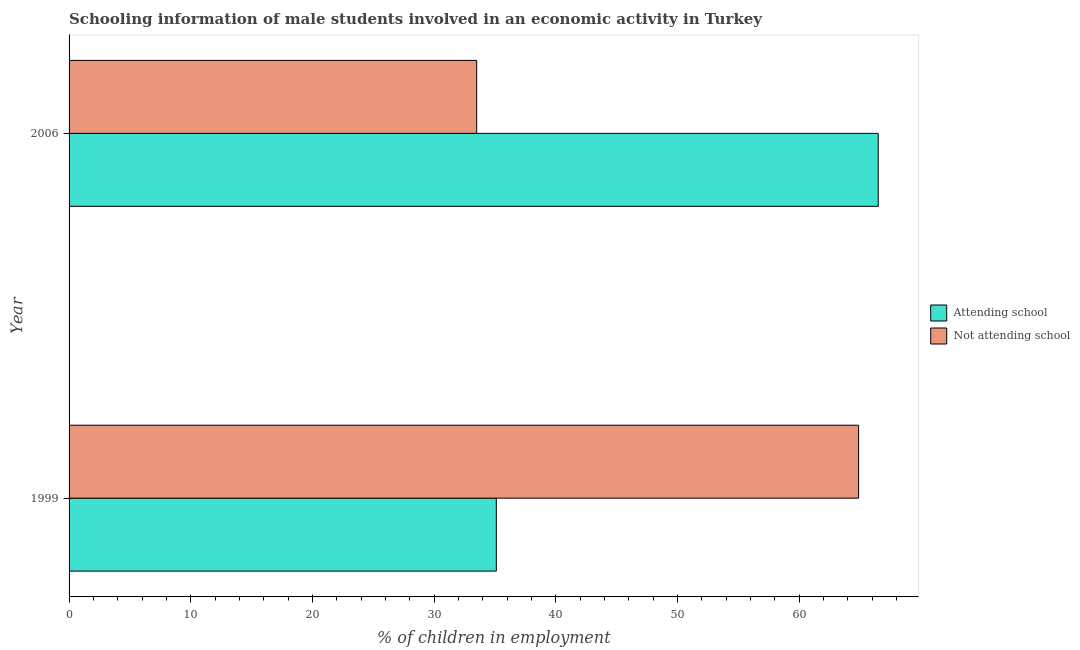Are the number of bars per tick equal to the number of legend labels?
Provide a succinct answer. Yes. Are the number of bars on each tick of the Y-axis equal?
Provide a short and direct response. Yes. How many bars are there on the 2nd tick from the bottom?
Your answer should be very brief. 2. What is the label of the 2nd group of bars from the top?
Give a very brief answer. 1999. What is the percentage of employed males who are attending school in 1999?
Your answer should be very brief. 35.11. Across all years, what is the maximum percentage of employed males who are attending school?
Your response must be concise. 66.5. Across all years, what is the minimum percentage of employed males who are not attending school?
Your response must be concise. 33.5. In which year was the percentage of employed males who are attending school minimum?
Keep it short and to the point. 1999. What is the total percentage of employed males who are not attending school in the graph?
Give a very brief answer. 98.39. What is the difference between the percentage of employed males who are attending school in 1999 and that in 2006?
Your answer should be very brief. -31.39. What is the difference between the percentage of employed males who are attending school in 2006 and the percentage of employed males who are not attending school in 1999?
Your response must be concise. 1.61. What is the average percentage of employed males who are not attending school per year?
Your answer should be compact. 49.19. In the year 2006, what is the difference between the percentage of employed males who are not attending school and percentage of employed males who are attending school?
Your answer should be very brief. -33. In how many years, is the percentage of employed males who are attending school greater than 56 %?
Provide a succinct answer. 1. What is the ratio of the percentage of employed males who are attending school in 1999 to that in 2006?
Offer a terse response. 0.53. Is the percentage of employed males who are attending school in 1999 less than that in 2006?
Provide a short and direct response. Yes. Is the difference between the percentage of employed males who are attending school in 1999 and 2006 greater than the difference between the percentage of employed males who are not attending school in 1999 and 2006?
Your answer should be compact. No. What does the 1st bar from the top in 2006 represents?
Your response must be concise. Not attending school. What does the 1st bar from the bottom in 1999 represents?
Offer a very short reply. Attending school. Does the graph contain any zero values?
Offer a very short reply. No. Does the graph contain grids?
Keep it short and to the point. No. How many legend labels are there?
Offer a very short reply. 2. What is the title of the graph?
Provide a short and direct response. Schooling information of male students involved in an economic activity in Turkey. Does "GDP at market prices" appear as one of the legend labels in the graph?
Make the answer very short. No. What is the label or title of the X-axis?
Give a very brief answer. % of children in employment. What is the % of children in employment of Attending school in 1999?
Ensure brevity in your answer.  35.11. What is the % of children in employment in Not attending school in 1999?
Give a very brief answer. 64.89. What is the % of children in employment of Attending school in 2006?
Keep it short and to the point. 66.5. What is the % of children in employment of Not attending school in 2006?
Provide a succinct answer. 33.5. Across all years, what is the maximum % of children in employment of Attending school?
Your answer should be compact. 66.5. Across all years, what is the maximum % of children in employment in Not attending school?
Offer a terse response. 64.89. Across all years, what is the minimum % of children in employment in Attending school?
Give a very brief answer. 35.11. Across all years, what is the minimum % of children in employment of Not attending school?
Keep it short and to the point. 33.5. What is the total % of children in employment in Attending school in the graph?
Offer a terse response. 101.61. What is the total % of children in employment of Not attending school in the graph?
Your response must be concise. 98.39. What is the difference between the % of children in employment in Attending school in 1999 and that in 2006?
Offer a very short reply. -31.39. What is the difference between the % of children in employment in Not attending school in 1999 and that in 2006?
Your response must be concise. 31.39. What is the difference between the % of children in employment of Attending school in 1999 and the % of children in employment of Not attending school in 2006?
Offer a very short reply. 1.61. What is the average % of children in employment of Attending school per year?
Offer a terse response. 50.81. What is the average % of children in employment of Not attending school per year?
Your answer should be very brief. 49.19. In the year 1999, what is the difference between the % of children in employment of Attending school and % of children in employment of Not attending school?
Give a very brief answer. -29.77. In the year 2006, what is the difference between the % of children in employment of Attending school and % of children in employment of Not attending school?
Keep it short and to the point. 33. What is the ratio of the % of children in employment of Attending school in 1999 to that in 2006?
Give a very brief answer. 0.53. What is the ratio of the % of children in employment of Not attending school in 1999 to that in 2006?
Make the answer very short. 1.94. What is the difference between the highest and the second highest % of children in employment of Attending school?
Ensure brevity in your answer.  31.39. What is the difference between the highest and the second highest % of children in employment of Not attending school?
Offer a very short reply. 31.39. What is the difference between the highest and the lowest % of children in employment of Attending school?
Your answer should be very brief. 31.39. What is the difference between the highest and the lowest % of children in employment in Not attending school?
Your answer should be very brief. 31.39. 